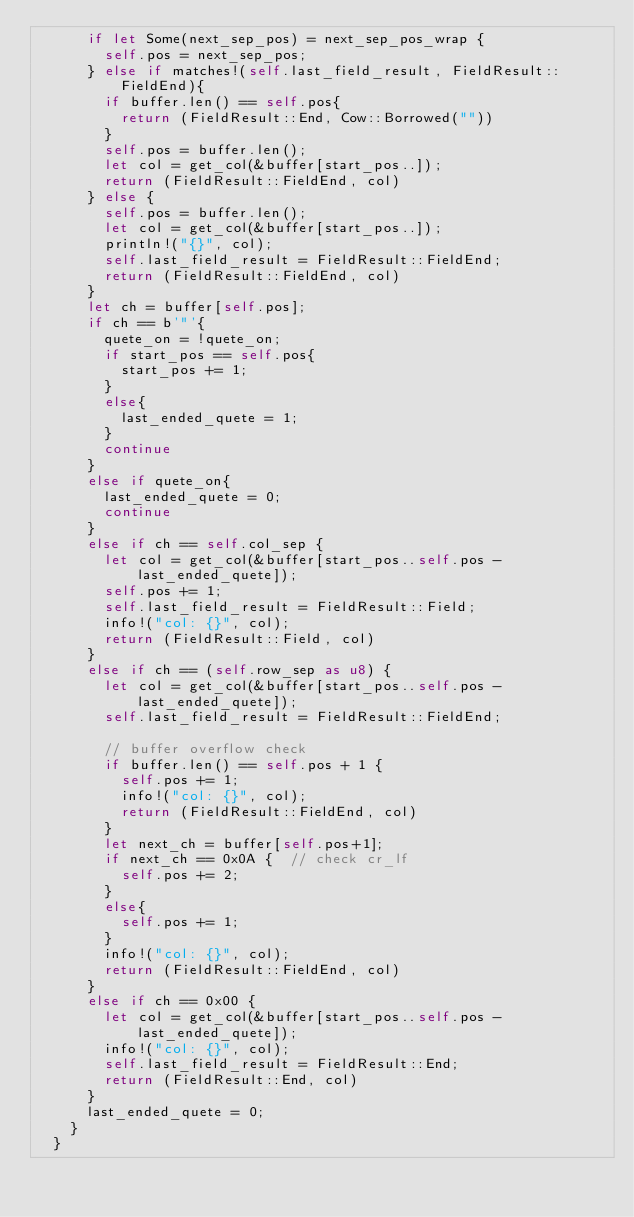Convert code to text. <code><loc_0><loc_0><loc_500><loc_500><_Rust_>			if let Some(next_sep_pos) = next_sep_pos_wrap {
				self.pos = next_sep_pos;
			} else if matches!(self.last_field_result, FieldResult::FieldEnd){
				if buffer.len() == self.pos{
					return (FieldResult::End, Cow::Borrowed(""))
				}
				self.pos = buffer.len();
				let col = get_col(&buffer[start_pos..]);
				return (FieldResult::FieldEnd, col)
			} else {
				self.pos = buffer.len();
				let col = get_col(&buffer[start_pos..]);
				println!("{}", col);
				self.last_field_result = FieldResult::FieldEnd;
				return (FieldResult::FieldEnd, col)
			}
			let ch = buffer[self.pos];
			if ch == b'"'{
				quete_on = !quete_on;
				if start_pos == self.pos{
					start_pos += 1;
				}
				else{
					last_ended_quete = 1;
				}
				continue
			}
			else if quete_on{
				last_ended_quete = 0;
				continue
			}
			else if ch == self.col_sep {
				let col = get_col(&buffer[start_pos..self.pos - last_ended_quete]);
				self.pos += 1;
				self.last_field_result = FieldResult::Field;
				info!("col: {}", col);
				return (FieldResult::Field, col)
			}
			else if ch == (self.row_sep as u8) {
				let col = get_col(&buffer[start_pos..self.pos - last_ended_quete]);
				self.last_field_result = FieldResult::FieldEnd;

				// buffer overflow check
				if buffer.len() == self.pos + 1 {
					self.pos += 1;
					info!("col: {}", col);
					return (FieldResult::FieldEnd, col)
				}
				let next_ch = buffer[self.pos+1];
				if next_ch == 0x0A {  // check cr_lf
					self.pos += 2;
				}
				else{
					self.pos += 1;
				}
				info!("col: {}", col);
				return (FieldResult::FieldEnd, col)
			}
			else if ch == 0x00 {
				let col = get_col(&buffer[start_pos..self.pos - last_ended_quete]);
				info!("col: {}", col);
				self.last_field_result = FieldResult::End;
				return (FieldResult::End, col)
			}
			last_ended_quete = 0;
		}
	}
</code> 